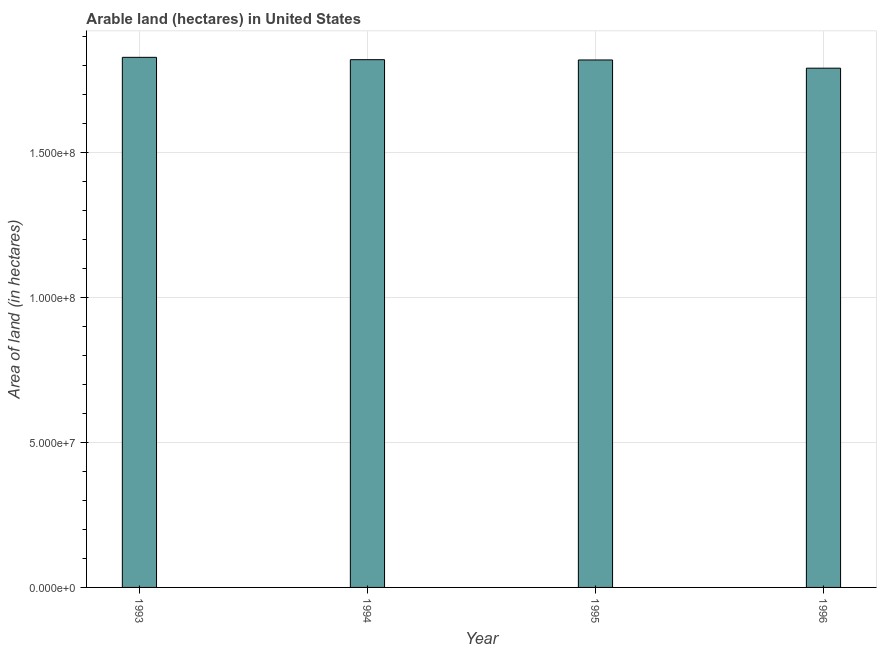Does the graph contain any zero values?
Offer a terse response. No. Does the graph contain grids?
Make the answer very short. Yes. What is the title of the graph?
Keep it short and to the point. Arable land (hectares) in United States. What is the label or title of the Y-axis?
Ensure brevity in your answer.  Area of land (in hectares). What is the area of land in 1995?
Make the answer very short. 1.82e+08. Across all years, what is the maximum area of land?
Your response must be concise. 1.83e+08. Across all years, what is the minimum area of land?
Ensure brevity in your answer.  1.79e+08. What is the sum of the area of land?
Your response must be concise. 7.26e+08. What is the difference between the area of land in 1994 and 1996?
Your response must be concise. 2.93e+06. What is the average area of land per year?
Make the answer very short. 1.81e+08. What is the median area of land?
Provide a succinct answer. 1.82e+08. Is the difference between the area of land in 1993 and 1995 greater than the difference between any two years?
Your response must be concise. No. What is the difference between the highest and the second highest area of land?
Give a very brief answer. 8.09e+05. Is the sum of the area of land in 1993 and 1995 greater than the maximum area of land across all years?
Keep it short and to the point. Yes. What is the difference between the highest and the lowest area of land?
Provide a succinct answer. 3.74e+06. How many bars are there?
Make the answer very short. 4. Are the values on the major ticks of Y-axis written in scientific E-notation?
Offer a very short reply. Yes. What is the Area of land (in hectares) in 1993?
Give a very brief answer. 1.83e+08. What is the Area of land (in hectares) of 1994?
Give a very brief answer. 1.82e+08. What is the Area of land (in hectares) of 1995?
Your answer should be very brief. 1.82e+08. What is the Area of land (in hectares) in 1996?
Provide a short and direct response. 1.79e+08. What is the difference between the Area of land (in hectares) in 1993 and 1994?
Ensure brevity in your answer.  8.09e+05. What is the difference between the Area of land (in hectares) in 1993 and 1995?
Your answer should be compact. 9.09e+05. What is the difference between the Area of land (in hectares) in 1993 and 1996?
Offer a terse response. 3.74e+06. What is the difference between the Area of land (in hectares) in 1994 and 1996?
Make the answer very short. 2.93e+06. What is the difference between the Area of land (in hectares) in 1995 and 1996?
Your answer should be very brief. 2.83e+06. What is the ratio of the Area of land (in hectares) in 1993 to that in 1996?
Offer a very short reply. 1.02. What is the ratio of the Area of land (in hectares) in 1994 to that in 1995?
Give a very brief answer. 1. What is the ratio of the Area of land (in hectares) in 1995 to that in 1996?
Offer a terse response. 1.02. 